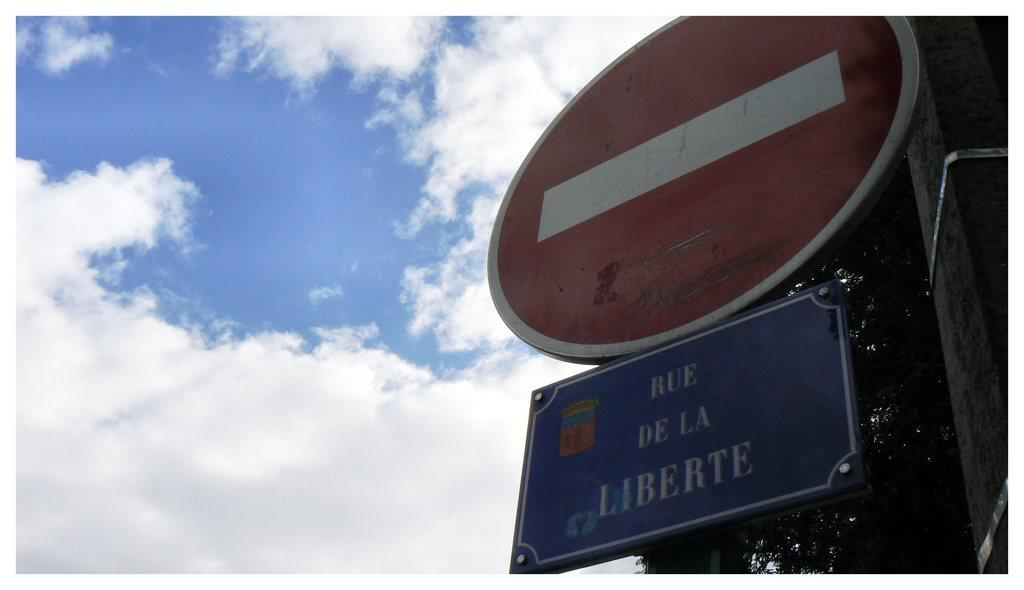<image>
Offer a succinct explanation of the picture presented. A sign reading Rue de la Liberte against a cloudy sky. 